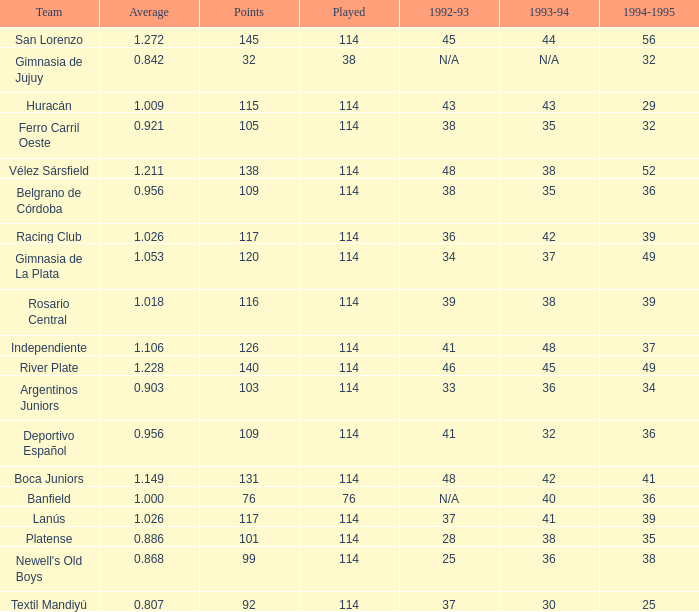Name the most played 114.0. 